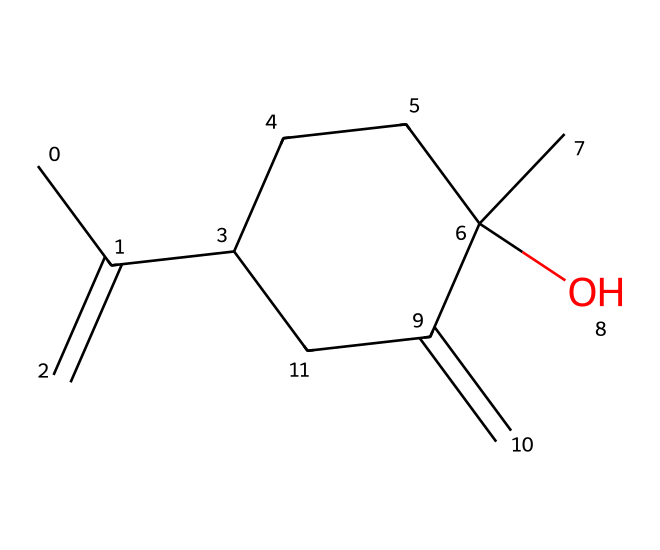How many carbon atoms are in the chemical structure? The SMILES representation indicates there are multiple "C" notations. Counting them gives a total of ten carbon atoms in the structure.
Answer: ten What is the molecular formula of this compound? By analyzing the structure, we gather that there are 10 carbon atoms, 16 hydrogen atoms, and 1 oxygen atom. Therefore, the molecular formula is C10H16O.
Answer: C10H16O What type of functional group is present in the chemical? Observing the structure, we see a hydroxyl group "OH" is attached to one of the carbon chains indicating that this compound has an alcohol functional group.
Answer: alcohol Which part of this chemical indicates it has a cyclic structure? The presence of "C1" in the SMILES suggests that there is a ring, and visualizing the structure reveals that it contains a cyclohexane ring, confirming its cyclic nature.
Answer: cyclohexane ring What type of compound is this based on its structure? Observing the multiple carbon-carbon double bonds and the alcohol group, this compound can be classified as a monoterpene alcohol, which is typical in essential oils like lavender.
Answer: monoterpene alcohol How many double bonds are present in the compound? By interpreting the SMILES notation, we can identify that there are two double bonds between carbon atoms in the structure.
Answer: two 